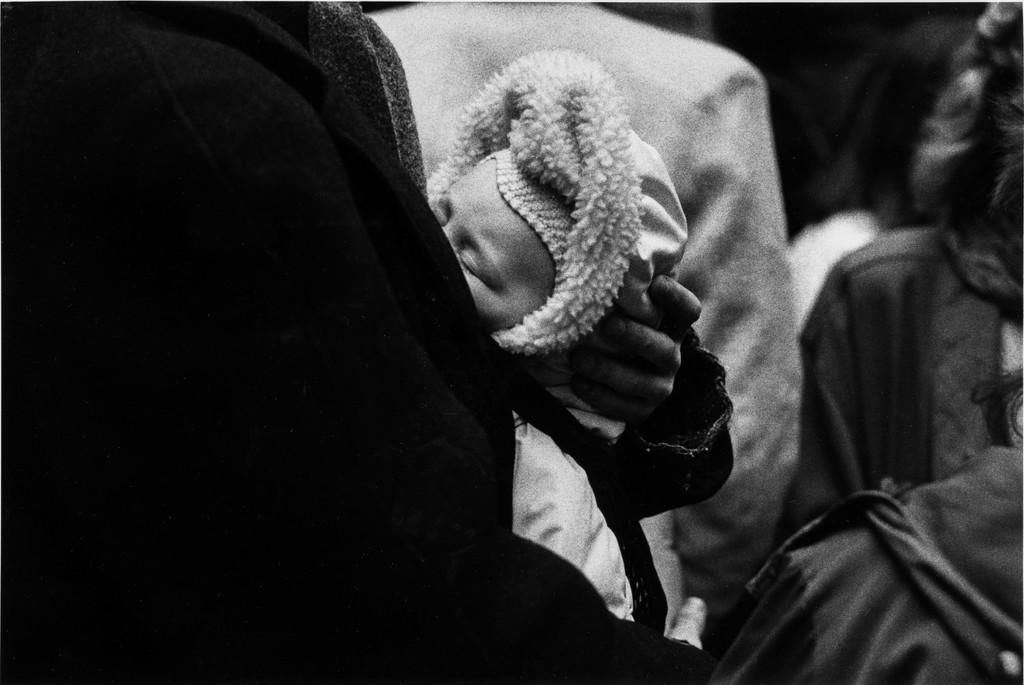Who or what is the main subject in the image? There is a person in the image. What is the person doing in the image? The person is holding a kid. What type of snake can be seen slithering near the person in the image? There is no snake present in the image; the person is holding a kid. 